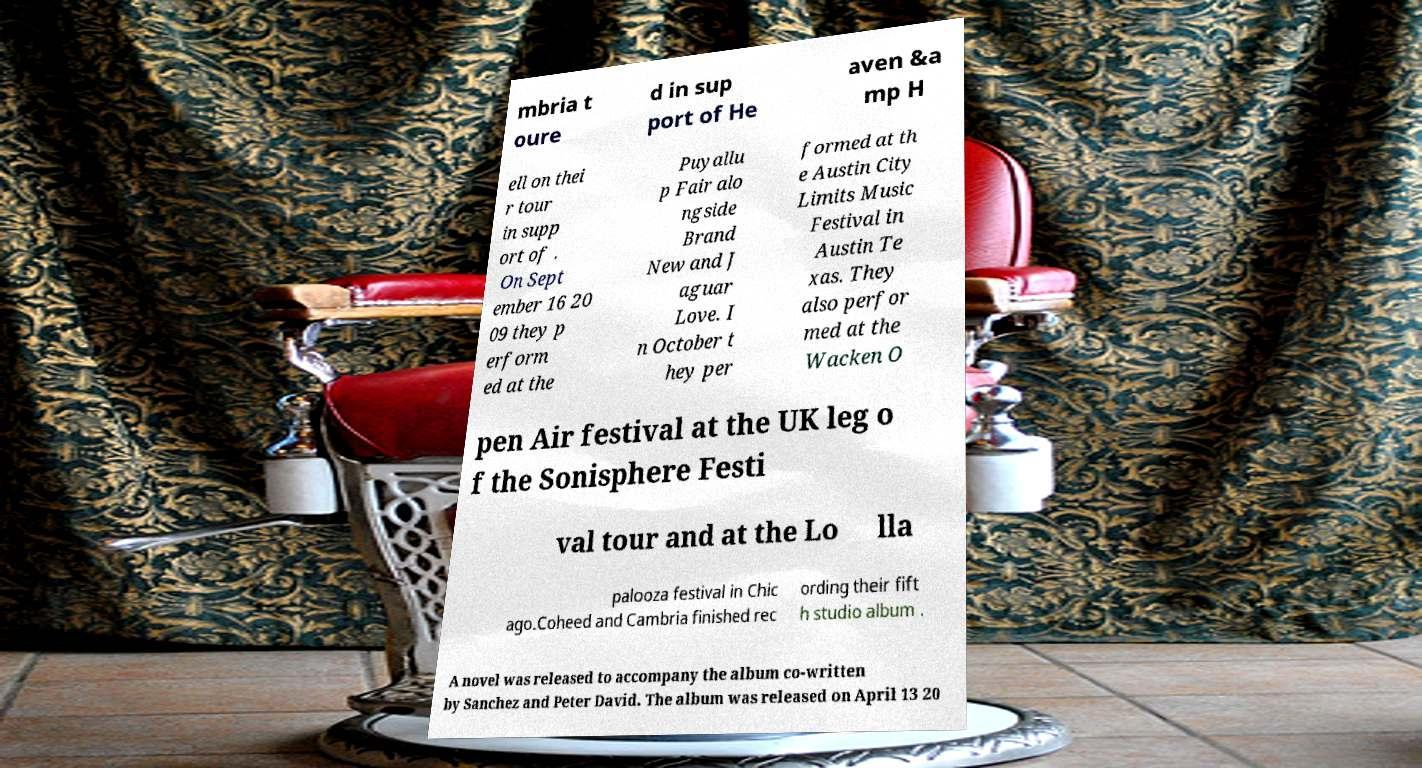There's text embedded in this image that I need extracted. Can you transcribe it verbatim? mbria t oure d in sup port of He aven &a mp H ell on thei r tour in supp ort of . On Sept ember 16 20 09 they p erform ed at the Puyallu p Fair alo ngside Brand New and J aguar Love. I n October t hey per formed at th e Austin City Limits Music Festival in Austin Te xas. They also perfor med at the Wacken O pen Air festival at the UK leg o f the Sonisphere Festi val tour and at the Lo lla palooza festival in Chic ago.Coheed and Cambria finished rec ording their fift h studio album . A novel was released to accompany the album co-written by Sanchez and Peter David. The album was released on April 13 20 